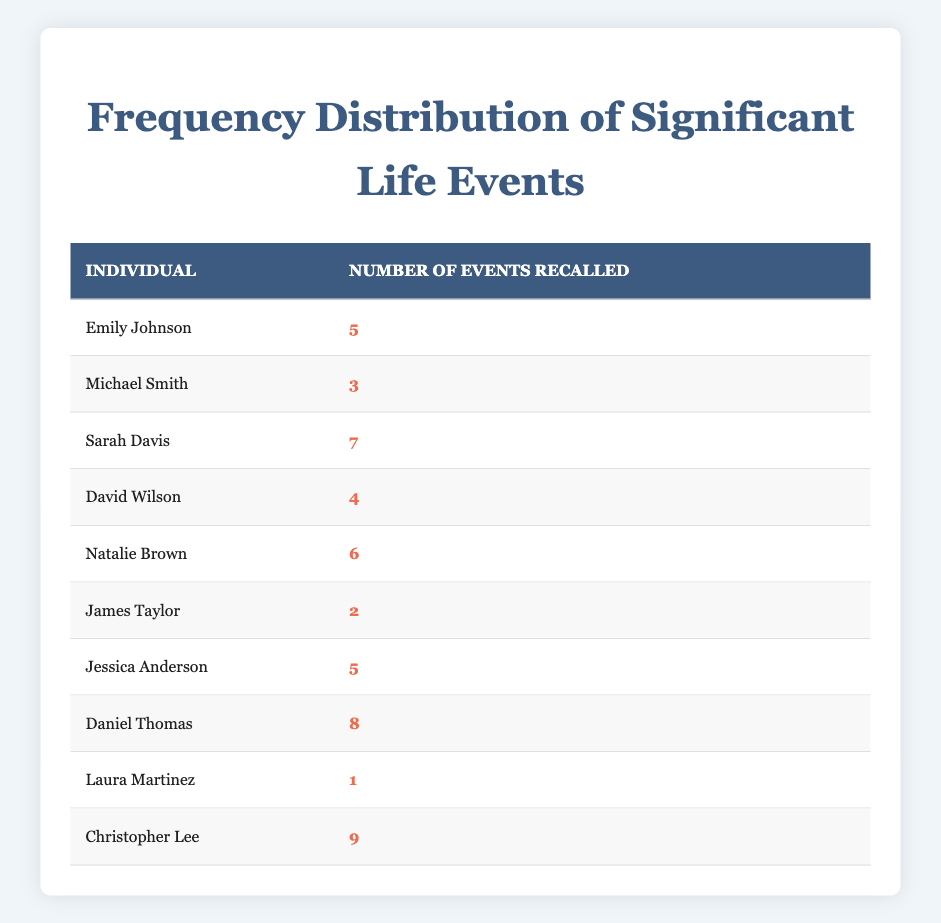What is the highest number of significant life events recalled by an individual? The highest number in the "Number of Events Recalled" column is 9, which corresponds to Christopher Lee.
Answer: 9 How many individuals recalled exactly 5 significant life events? There are two entries with the number 5 in the "Number of Events Recalled": Emily Johnson and Jessica Anderson.
Answer: 2 Who recalled the least number of significant life events? The individual with the least number of events recalled is Laura Martinez, with 1 event.
Answer: Laura Martinez What is the average number of significant life events recalled by all individuals? To find the average, add all the recalled events: (5 + 3 + 7 + 4 + 6 + 2 + 5 + 8 + 1 + 9) = 50. There are 10 individuals, so 50 divided by 10 equals 5.
Answer: 5 Is it true that all individuals recalled more than 2 significant life events? No, it is false because James Taylor recalled only 2 events and Laura Martinez recalled just 1.
Answer: False What is the difference between the highest and lowest number of events recalled? The highest number is 9 (Christopher Lee), and the lowest is 1 (Laura Martinez). The difference is 9 - 1 = 8.
Answer: 8 How many individuals recalled a number of significant life events greater than 5? The individuals with more than 5 events are Sarah Davis (7), Natalie Brown (6), Daniel Thomas (8), and Christopher Lee (9). That totals 4 individuals.
Answer: 4 Which individual recalled one fewer significant life event than Natalie Brown? Natalie Brown recalled 6 events, so one fewer would be 5. The individuals who recalled 5 events are Emily Johnson and Jessica Anderson.
Answer: Emily Johnson, Jessica Anderson How many individuals recalled between 4 and 6 significant life events, inclusive? The individuals recalling 4 events are David Wilson, 5 events are Emily Johnson and Jessica Anderson, and 6 events is Natalie Brown, totaling 4 individuals (David Wilson, Emily Johnson, Jessica Anderson, Natalie Brown).
Answer: 4 